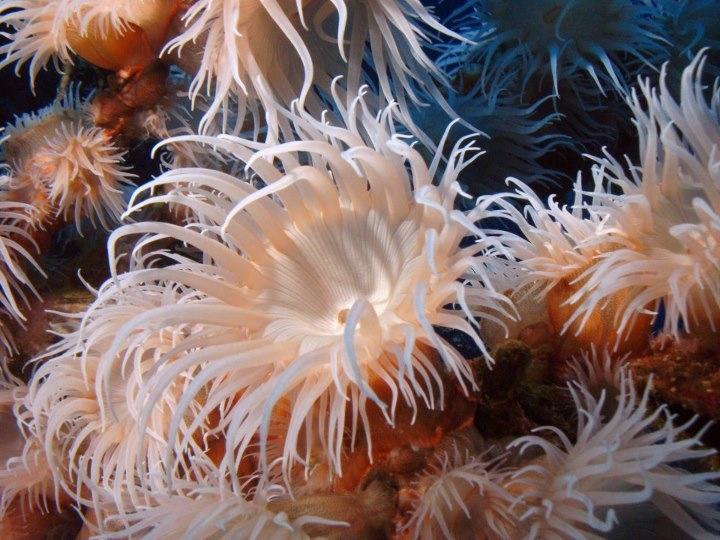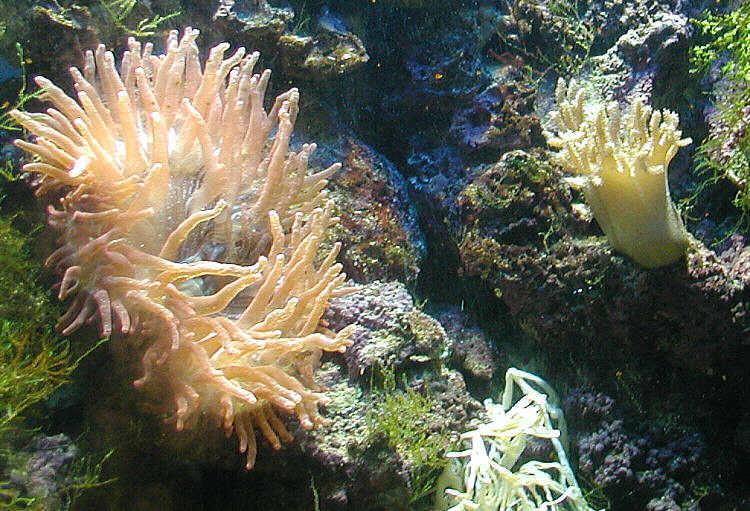The first image is the image on the left, the second image is the image on the right. Assess this claim about the two images: "Left image shows at least five of the same type of anemones with pale tendrils.". Correct or not? Answer yes or no. Yes. 